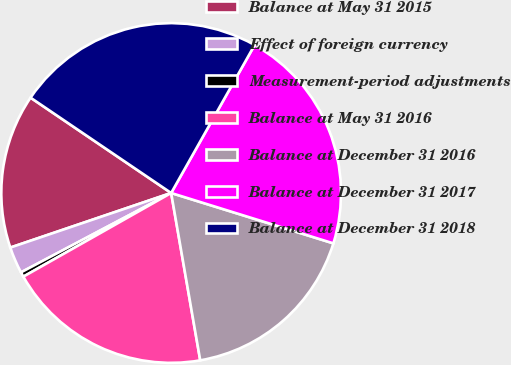Convert chart to OTSL. <chart><loc_0><loc_0><loc_500><loc_500><pie_chart><fcel>Balance at May 31 2015<fcel>Effect of foreign currency<fcel>Measurement-period adjustments<fcel>Balance at May 31 2016<fcel>Balance at December 31 2016<fcel>Balance at December 31 2017<fcel>Balance at December 31 2018<nl><fcel>14.69%<fcel>2.53%<fcel>0.46%<fcel>19.54%<fcel>17.47%<fcel>21.62%<fcel>23.69%<nl></chart> 